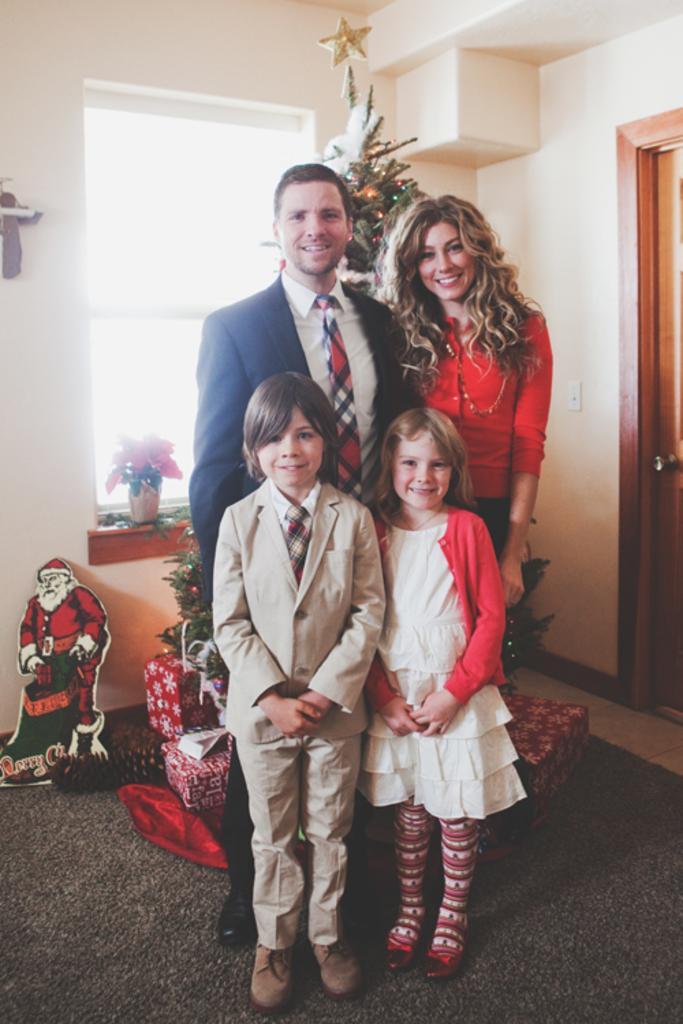Can you describe this image briefly? In this picture we can see there are four people standing on the carpet and behind the people there is a tree and it is decorated with some items. Behind the tree there is a house plant, gift boxes and a wall with a wooden door. 